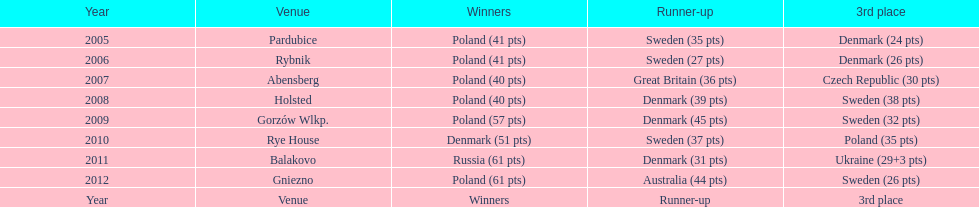Could you parse the entire table? {'header': ['Year', 'Venue', 'Winners', 'Runner-up', '3rd place'], 'rows': [['2005', 'Pardubice', 'Poland (41 pts)', 'Sweden (35 pts)', 'Denmark (24 pts)'], ['2006', 'Rybnik', 'Poland (41 pts)', 'Sweden (27 pts)', 'Denmark (26 pts)'], ['2007', 'Abensberg', 'Poland (40 pts)', 'Great Britain (36 pts)', 'Czech Republic (30 pts)'], ['2008', 'Holsted', 'Poland (40 pts)', 'Denmark (39 pts)', 'Sweden (38 pts)'], ['2009', 'Gorzów Wlkp.', 'Poland (57 pts)', 'Denmark (45 pts)', 'Sweden (32 pts)'], ['2010', 'Rye House', 'Denmark (51 pts)', 'Sweden (37 pts)', 'Poland (35 pts)'], ['2011', 'Balakovo', 'Russia (61 pts)', 'Denmark (31 pts)', 'Ukraine (29+3 pts)'], ['2012', 'Gniezno', 'Poland (61 pts)', 'Australia (44 pts)', 'Sweden (26 pts)'], ['Year', 'Venue', 'Winners', 'Runner-up', '3rd place']]} Which team has the most third place wins in the speedway junior world championship between 2005 and 2012? Sweden. 